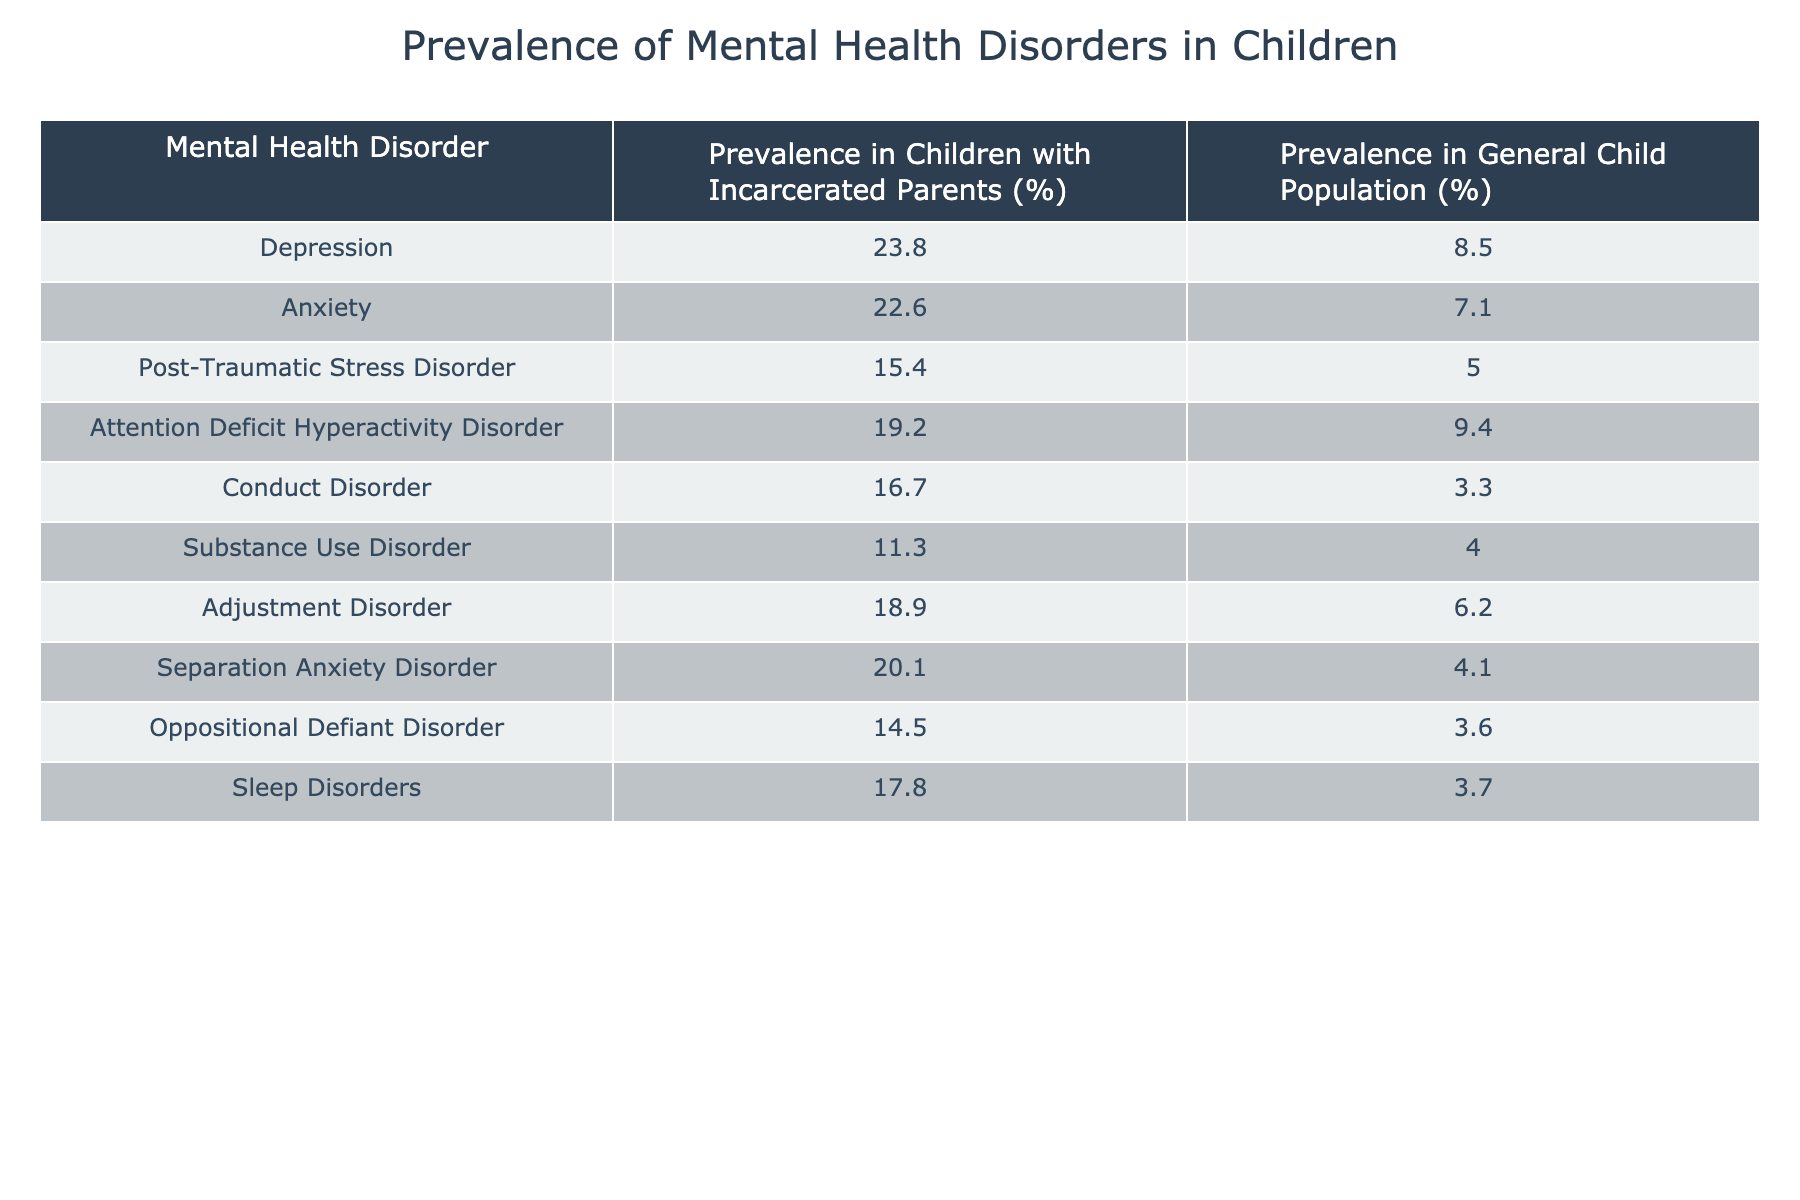What is the prevalence of depression in children with incarcerated parents? The table indicates that the prevalence of depression in this group is 23.8%.
Answer: 23.8% How does the prevalence of anxiety in children with incarcerated parents compare to the general child population? The table shows that the prevalence of anxiety is 22.6% in children with incarcerated parents and 7.1% in the general population. The difference is 22.6% - 7.1% = 15.5%.
Answer: 15.5% What is the prevalence of conduct disorder in children with incarcerated parents? The table indicates that the prevalence of conduct disorder in this group is 16.7%.
Answer: 16.7% Is the prevalence of post-traumatic stress disorder higher in children with incarcerated parents or in the general child population? The table shows 15.4% for children with incarcerated parents and 5.0% for the general population. Therefore, it is higher in children with incarcerated parents.
Answer: Yes What percentage of children with incarcerated parents experience separation anxiety disorder? The table displays that the prevalence of separation anxiety disorder in this group is 20.1%.
Answer: 20.1% Which mental health disorder has the highest prevalence in children with incarcerated parents? Looking at the table, depression has the highest prevalence at 23.8% compared to other disorders listed.
Answer: Depression Calculate the average prevalence of all mental health disorders listed for children with incarcerated parents. To find the average, sum all the percentages: 23.8 + 22.6 + 15.4 + 19.2 + 16.7 + 11.3 + 18.9 + 20.1 + 14.5 + 17.8 =  180.3%. There are 10 disorders, so the average is 180.3% / 10 = 18.03%.
Answer: 18.03% What is the difference in prevalence of adjustment disorder between the two populations? The prevalence of adjustment disorder in children with incarcerated parents is 18.9%, and in the general population, it is 6.2%. The difference is 18.9% - 6.2% = 12.7%.
Answer: 12.7% How many of the listed mental health disorders have a prevalence of over 15% in children with incarcerated parents? By examining the table, there are 6 disorders (depression, anxiety, attention deficit hyperactivity disorder, conduct disorder, separation anxiety disorder, and adjustment disorder) with prevalence rates over 15%.
Answer: 6 Are sleep disorders more prevalent in children with incarcerated parents compared to the general population? According to the table, sleep disorders have 17.8% prevalence in children with incarcerated parents and 3.7% in the general population, indicating they are more prevalent in the former.
Answer: Yes 